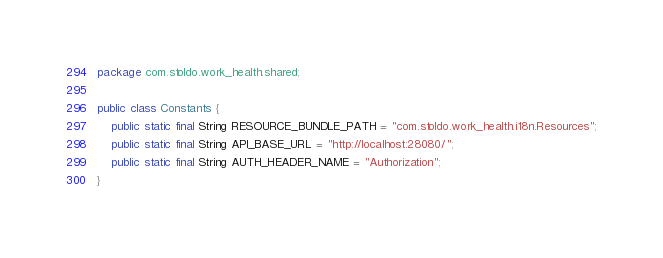<code> <loc_0><loc_0><loc_500><loc_500><_Java_>package com.stoldo.work_health.shared;

public class Constants {
	public static final String RESOURCE_BUNDLE_PATH = "com.stoldo.work_health.i18n.Resources";
	public static final String API_BASE_URL = "http://localhost:28080/";
	public static final String AUTH_HEADER_NAME = "Authorization";
}
</code> 